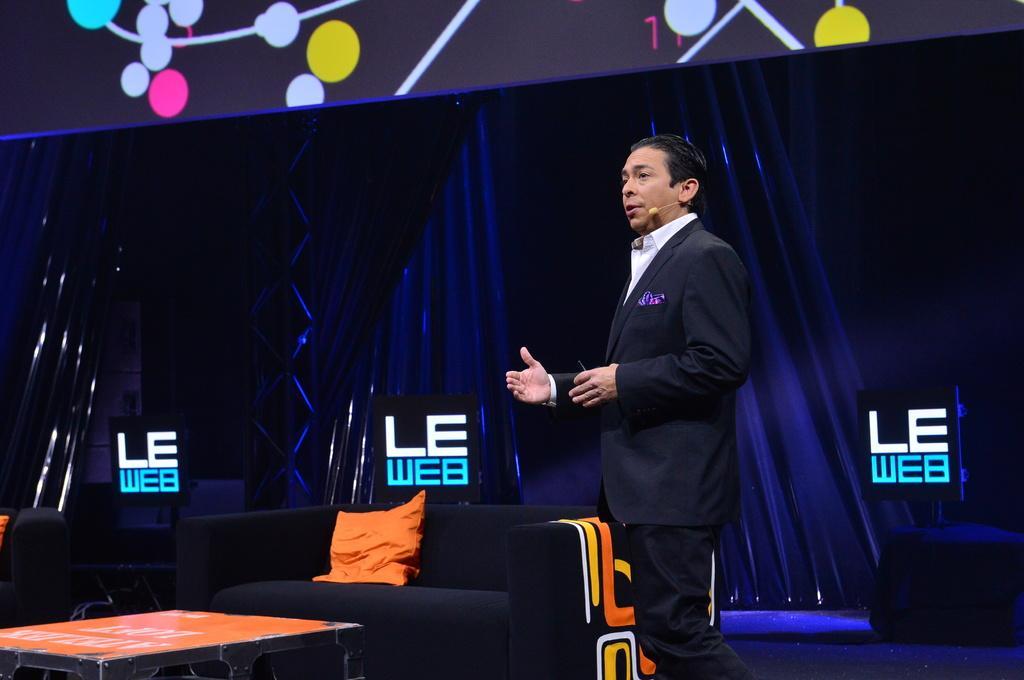Can you describe this image briefly? In the center of the image, we can see a man standing and wearing a coat and there is a mic to him. In the background, there is board and we can see a curtain and some other boards and there are sofas and we can see a cushion and there is a table. 